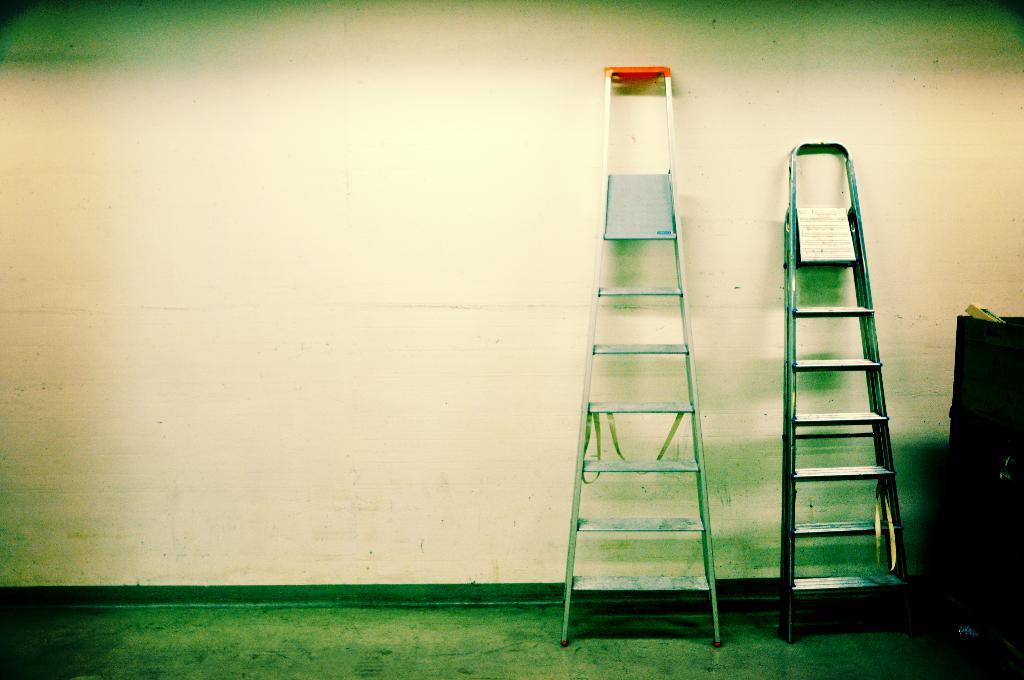Could you give a brief overview of what you see in this image? In this picture we can see ladders on the floor, here we can see an object and we can see a wall in the background. 